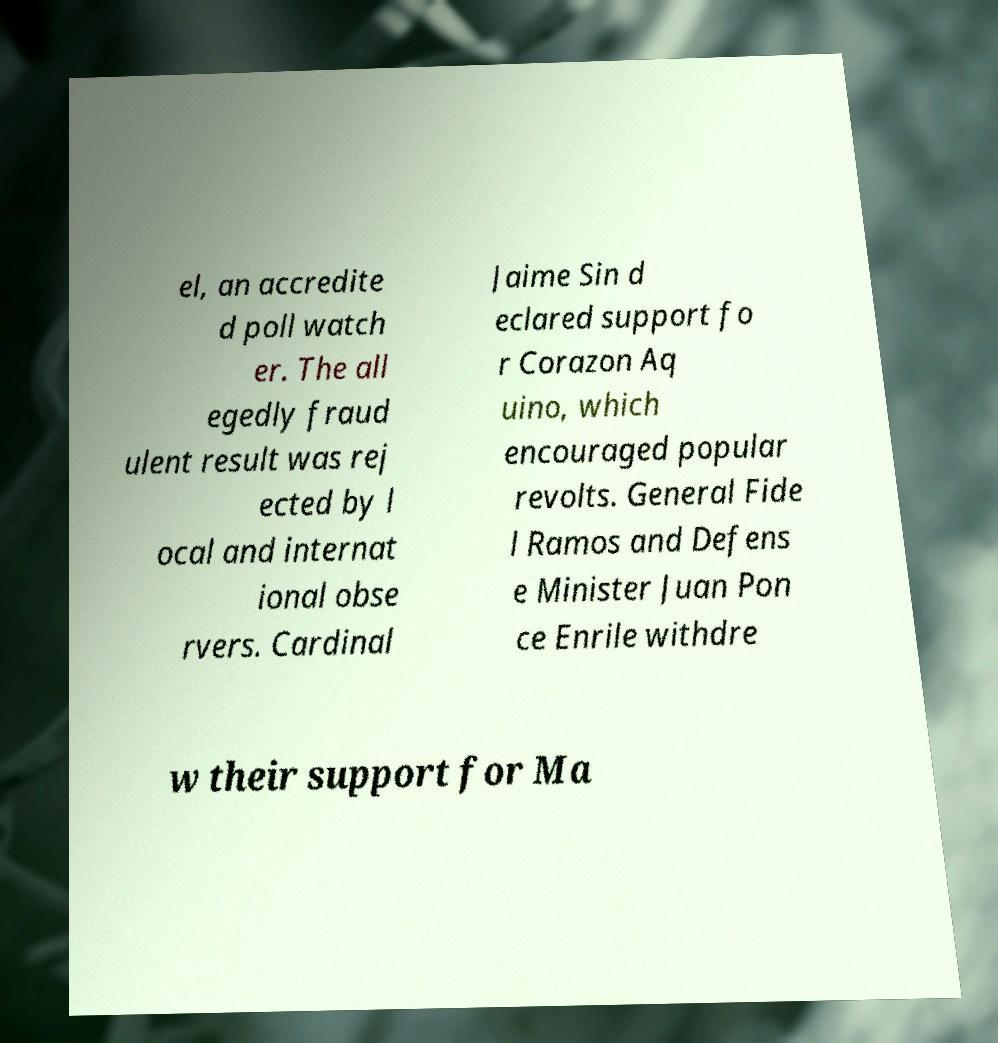For documentation purposes, I need the text within this image transcribed. Could you provide that? el, an accredite d poll watch er. The all egedly fraud ulent result was rej ected by l ocal and internat ional obse rvers. Cardinal Jaime Sin d eclared support fo r Corazon Aq uino, which encouraged popular revolts. General Fide l Ramos and Defens e Minister Juan Pon ce Enrile withdre w their support for Ma 